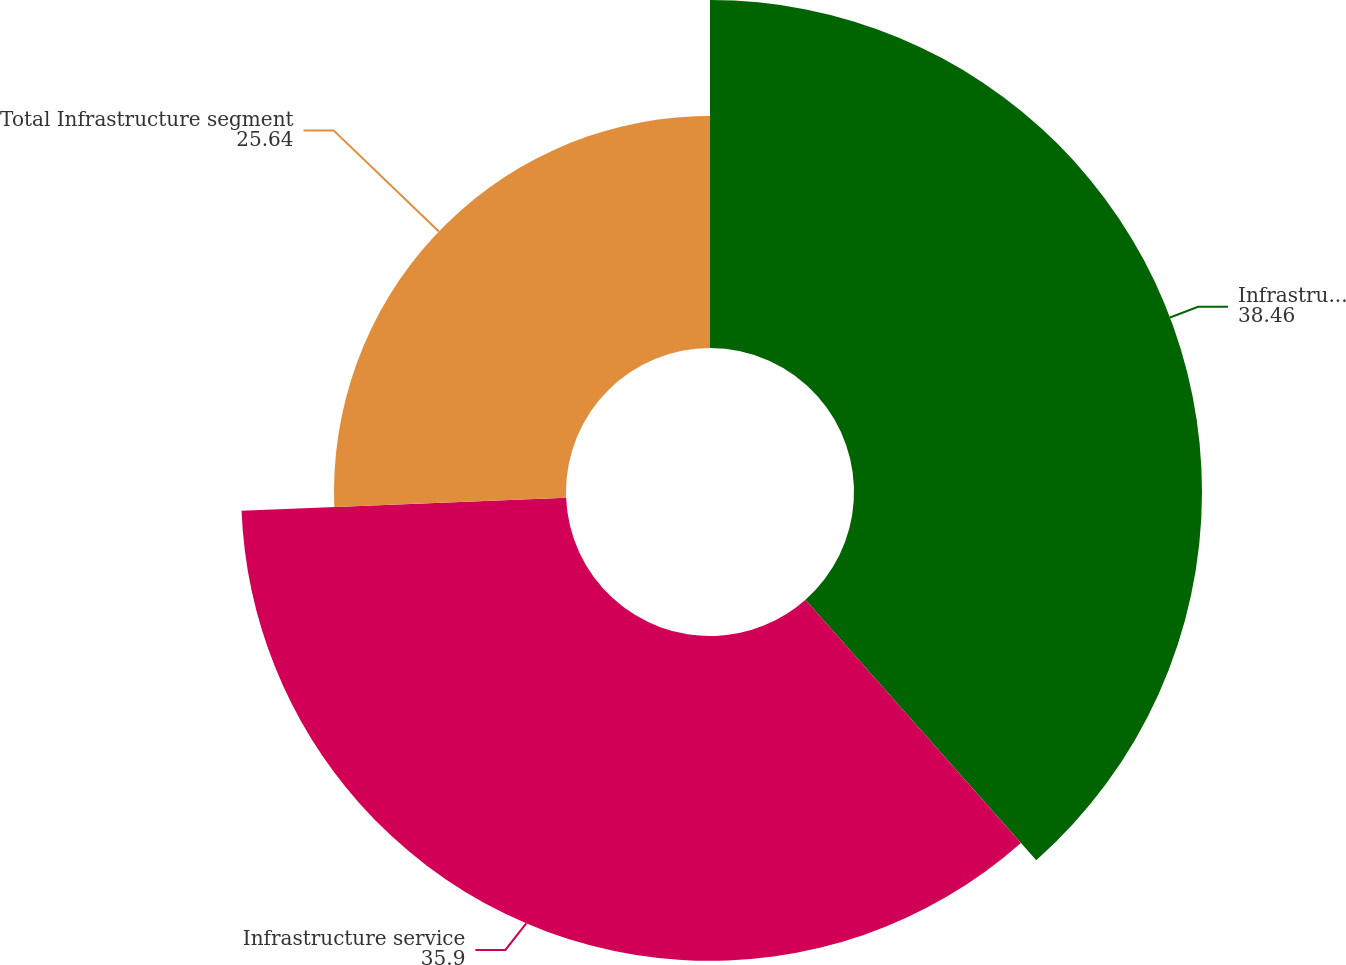Convert chart to OTSL. <chart><loc_0><loc_0><loc_500><loc_500><pie_chart><fcel>Infrastructure product<fcel>Infrastructure service<fcel>Total Infrastructure segment<nl><fcel>38.46%<fcel>35.9%<fcel>25.64%<nl></chart> 